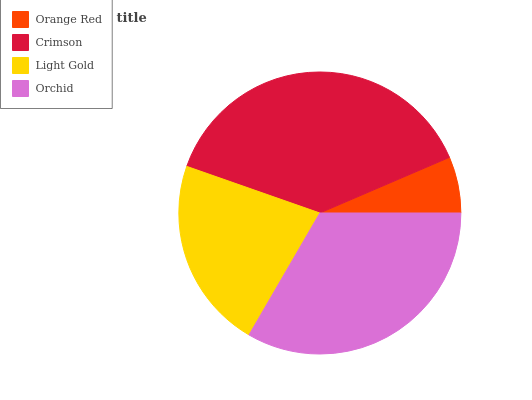Is Orange Red the minimum?
Answer yes or no. Yes. Is Crimson the maximum?
Answer yes or no. Yes. Is Light Gold the minimum?
Answer yes or no. No. Is Light Gold the maximum?
Answer yes or no. No. Is Crimson greater than Light Gold?
Answer yes or no. Yes. Is Light Gold less than Crimson?
Answer yes or no. Yes. Is Light Gold greater than Crimson?
Answer yes or no. No. Is Crimson less than Light Gold?
Answer yes or no. No. Is Orchid the high median?
Answer yes or no. Yes. Is Light Gold the low median?
Answer yes or no. Yes. Is Orange Red the high median?
Answer yes or no. No. Is Orange Red the low median?
Answer yes or no. No. 